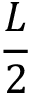<formula> <loc_0><loc_0><loc_500><loc_500>\frac { L } { 2 }</formula> 